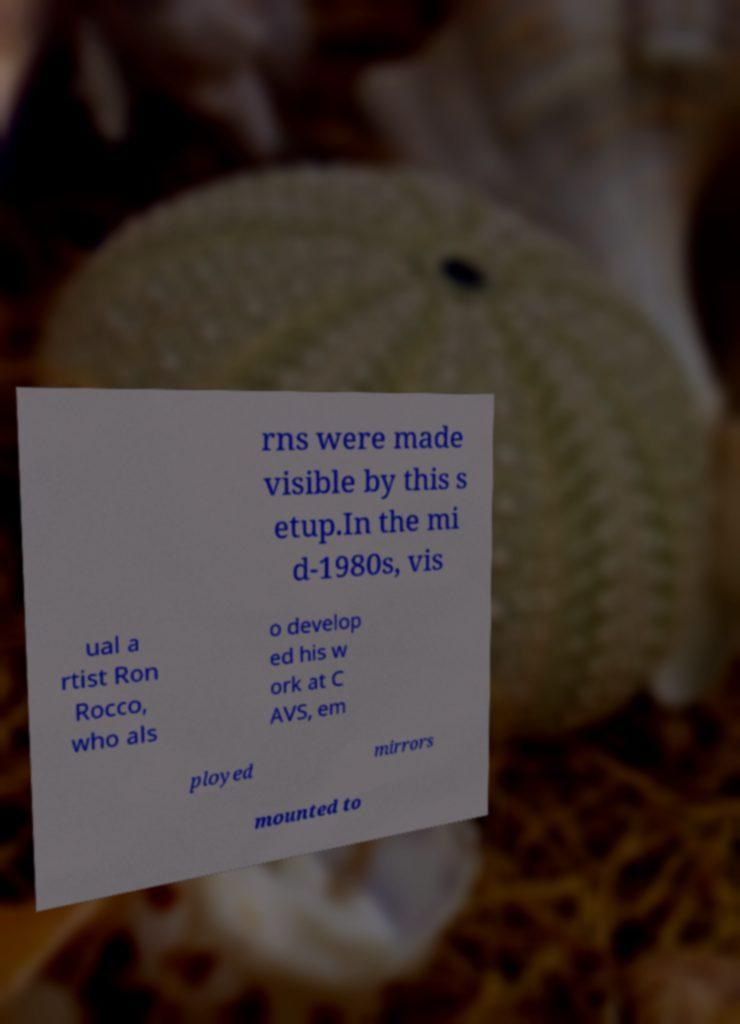Could you extract and type out the text from this image? rns were made visible by this s etup.In the mi d-1980s, vis ual a rtist Ron Rocco, who als o develop ed his w ork at C AVS, em ployed mirrors mounted to 